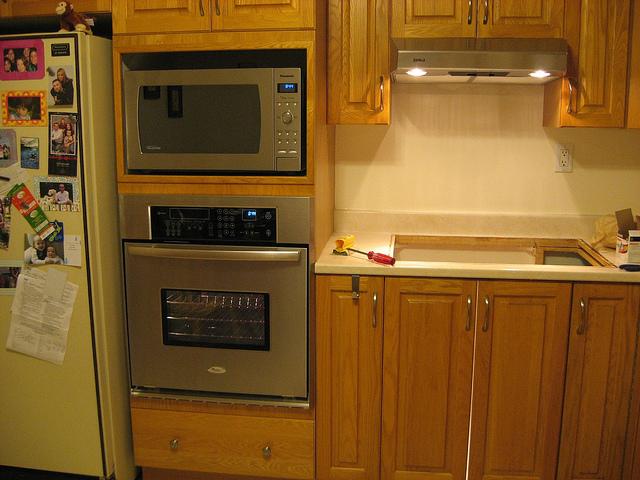Where is the microwave?
Be succinct. Above oven. What is missing from the kitchen?
Be succinct. Sink. Why is there light coming through the cabinet doors?
Write a very short answer. Yes. 